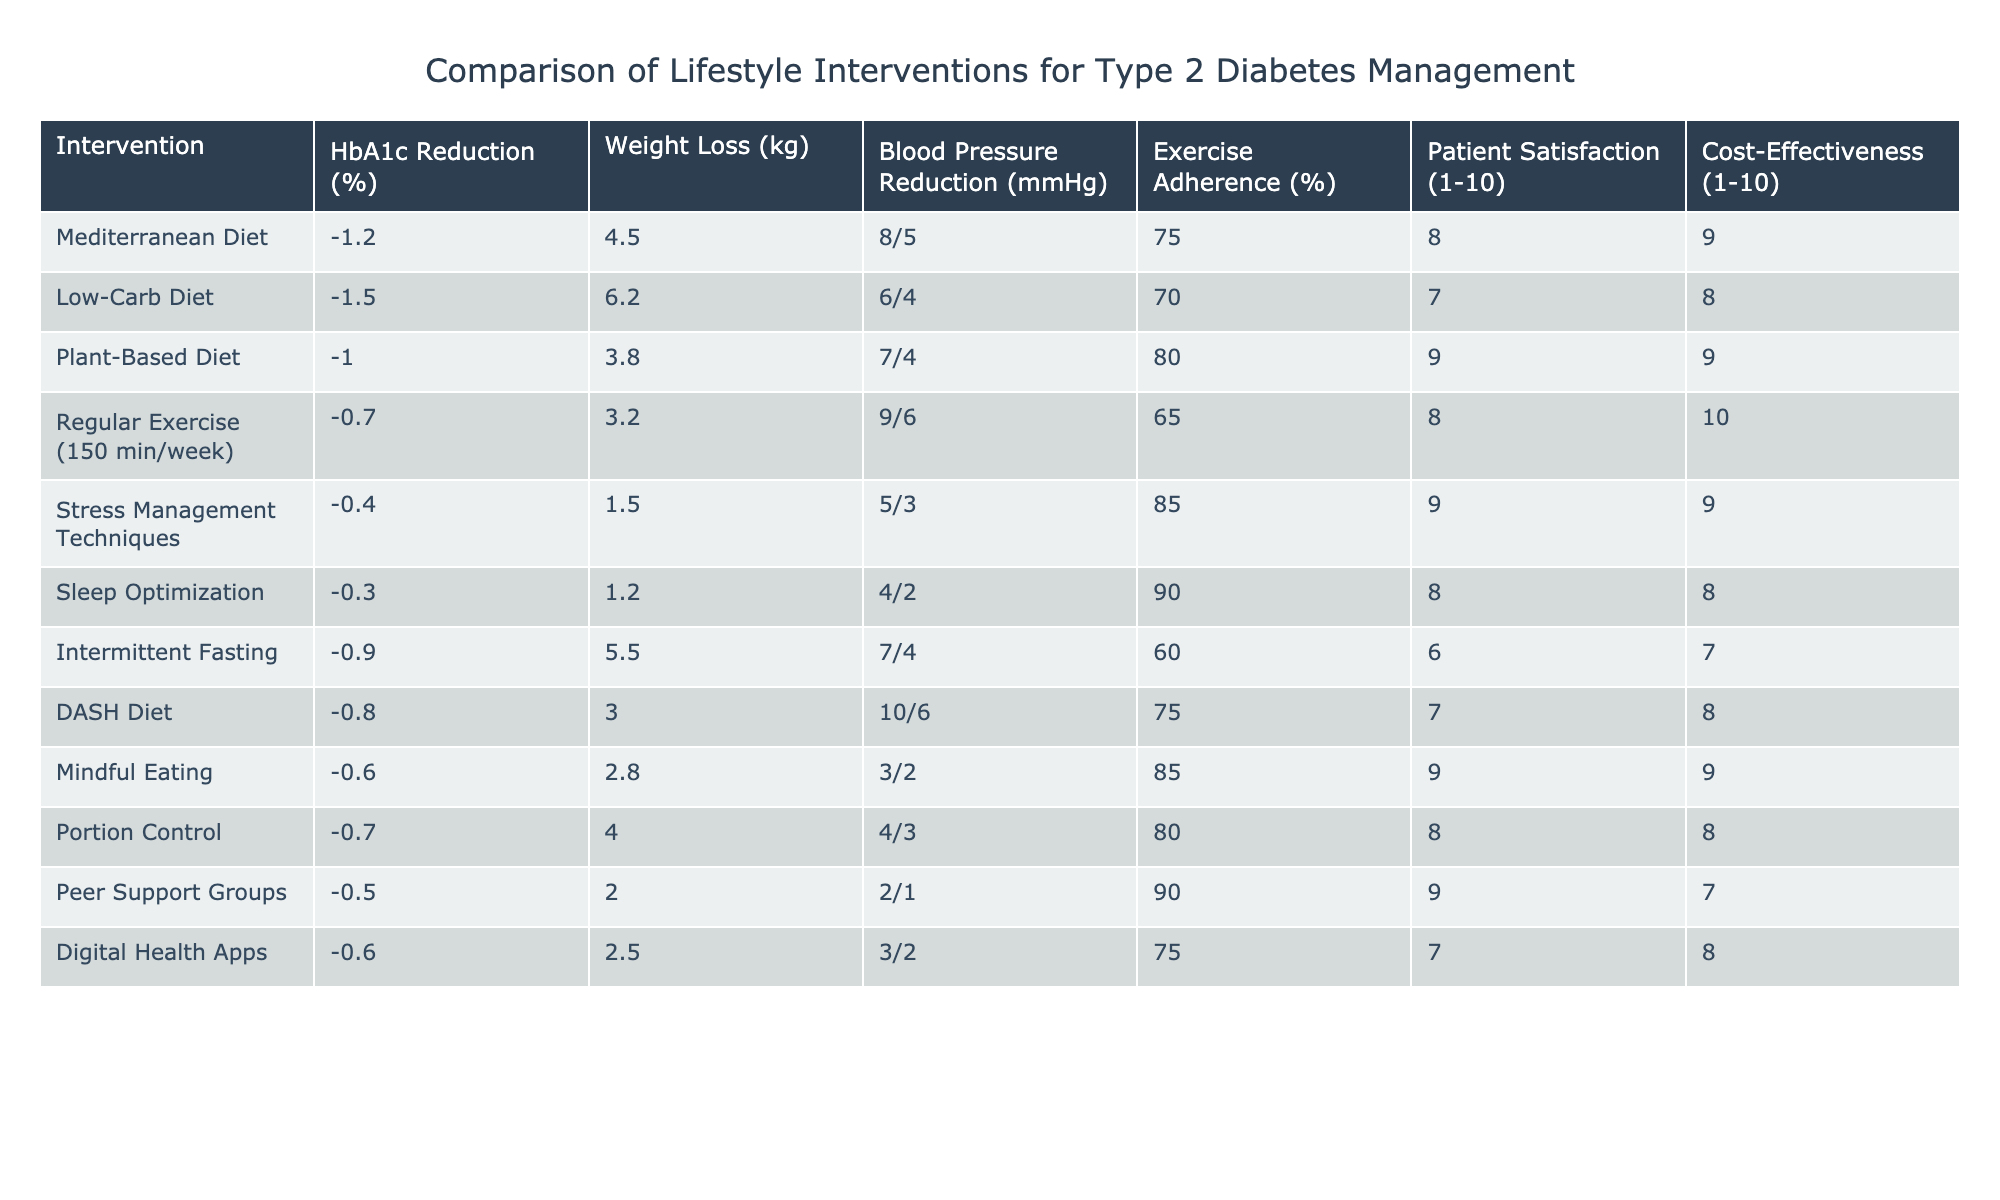What is the HbA1c reduction for the Low-Carb Diet? The table shows that the HbA1c reduction for the Low-Carb Diet is listed as -1.5%.
Answer: -1.5% Which intervention has the highest patient satisfaction rating? Looking through the Patient Satisfaction column, the Plant-Based Diet and Mindful Eating both have the highest rating of 9.
Answer: Plant-Based Diet and Mindful Eating What is the average weight loss from the Regular Exercise intervention? The Regular Exercise intervention has a weight loss of 3.2 kg. Since we are only looking at this one data point, the average is simply 3.2 kg.
Answer: 3.2 kg Is there an intervention that shows a positive reduction in blood pressure more than 8 mmHg? Referring to the Blood Pressure Reduction column, the Regular Exercise intervention shows a reduction of 9 mmHg, which is above 8 mmHg.
Answer: Yes Which intervention simultaneously provides the best cost-effectiveness and blood pressure reduction? Looking at the table, the Regular Exercise intervention has the highest cost-effectiveness rating of 10 and also provides a blood pressure reduction of 9 mmHg, which is higher than all the others available.
Answer: Regular Exercise What is the difference in weight loss between the Low-Carb Diet and the Mediterranean Diet? The weight loss for the Low-Carb Diet is 6.2 kg and for the Mediterranean Diet is 4.5 kg. The difference in weight loss is calculated as 6.2 kg - 4.5 kg = 1.7 kg.
Answer: 1.7 kg Which two interventions have the highest adherence rates to exercise? Checking the Exercise Adherence column, the Stress Management Techniques have an adherence rate of 85% and Sleep Optimization has 90%, making them the highest.
Answer: Sleep Optimization and Stress Management Techniques Is the Mediterranean Diet more cost-effective than the Intermittent Fasting? The Mediterranean Diet has a cost-effectiveness rating of 9 while Intermittent Fasting has a rating of 7. Therefore, the Mediterranean Diet is more cost-effective.
Answer: Yes How do the blood pressure reductions for the DASH Diet and the Plant-Based Diet compare? The DASH Diet shows a blood pressure reduction of 10/6 mmHg and the Plant-Based Diet shows a reduction of 7/4 mmHg. Comparing them shows that the DASH Diet has a higher reduction in both systolic and diastolic measurements.
Answer: DASH Diet is higher 